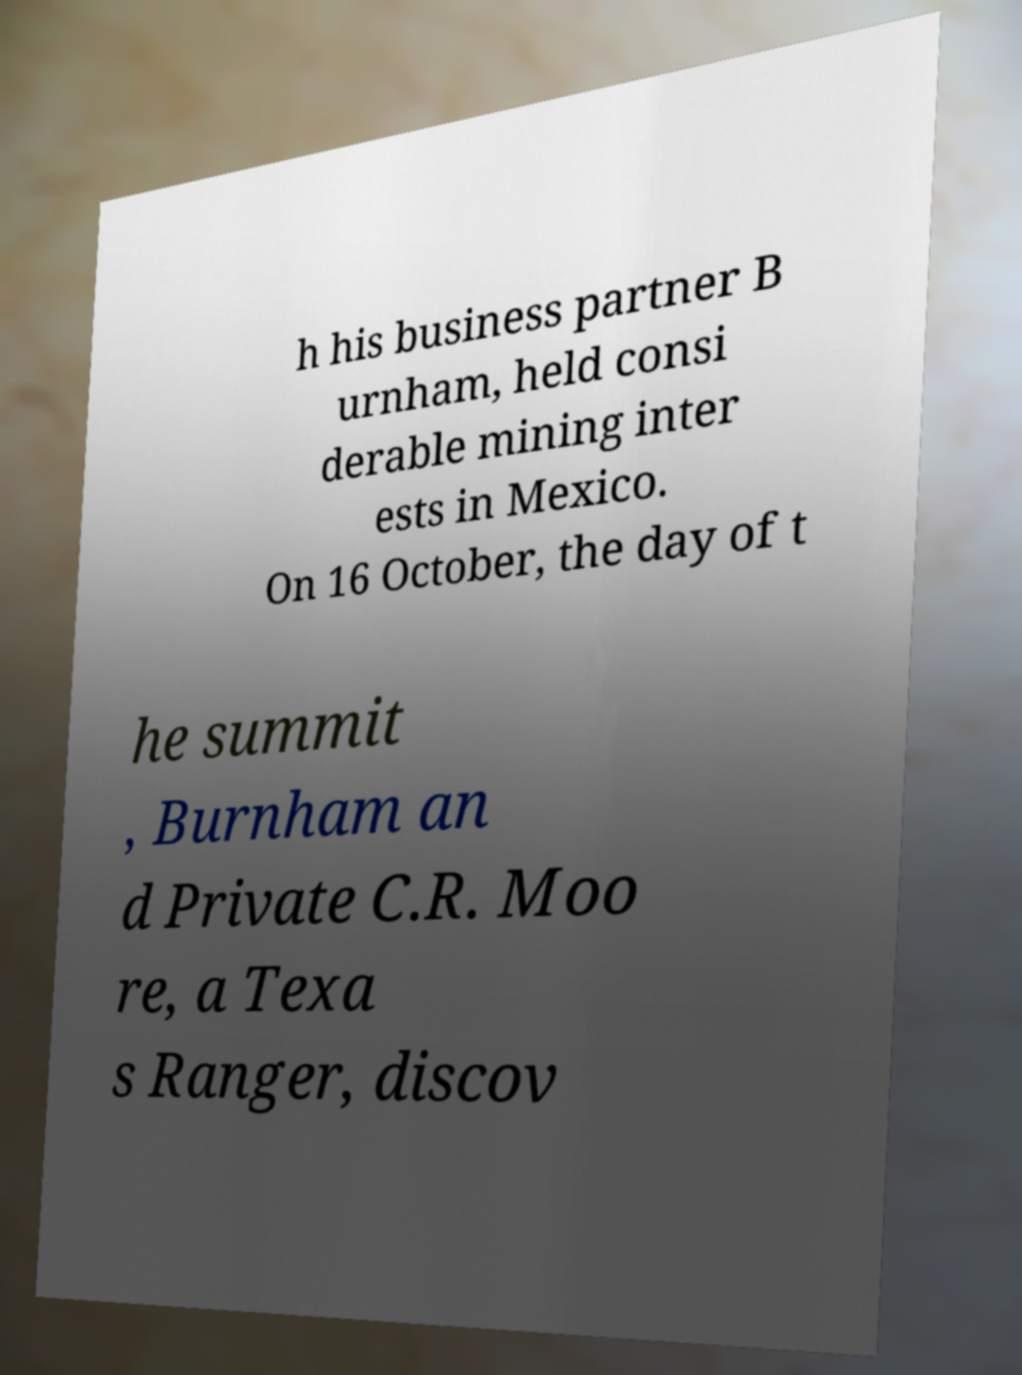Please read and relay the text visible in this image. What does it say? h his business partner B urnham, held consi derable mining inter ests in Mexico. On 16 October, the day of t he summit , Burnham an d Private C.R. Moo re, a Texa s Ranger, discov 